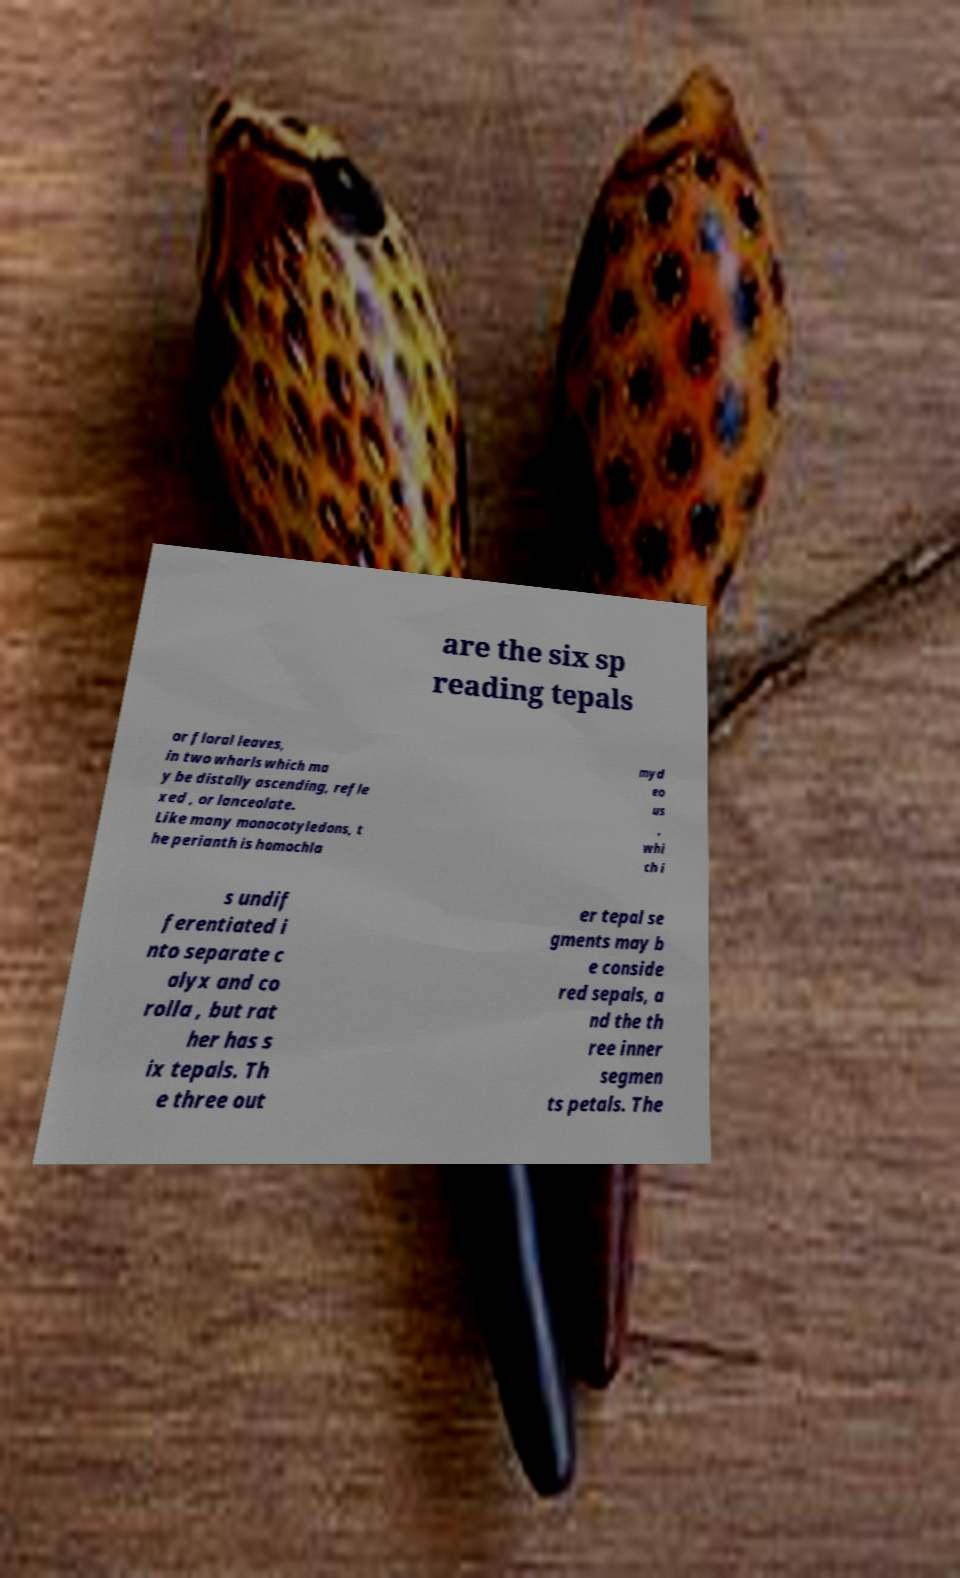Could you extract and type out the text from this image? are the six sp reading tepals or floral leaves, in two whorls which ma y be distally ascending, refle xed , or lanceolate. Like many monocotyledons, t he perianth is homochla myd eo us , whi ch i s undif ferentiated i nto separate c alyx and co rolla , but rat her has s ix tepals. Th e three out er tepal se gments may b e conside red sepals, a nd the th ree inner segmen ts petals. The 